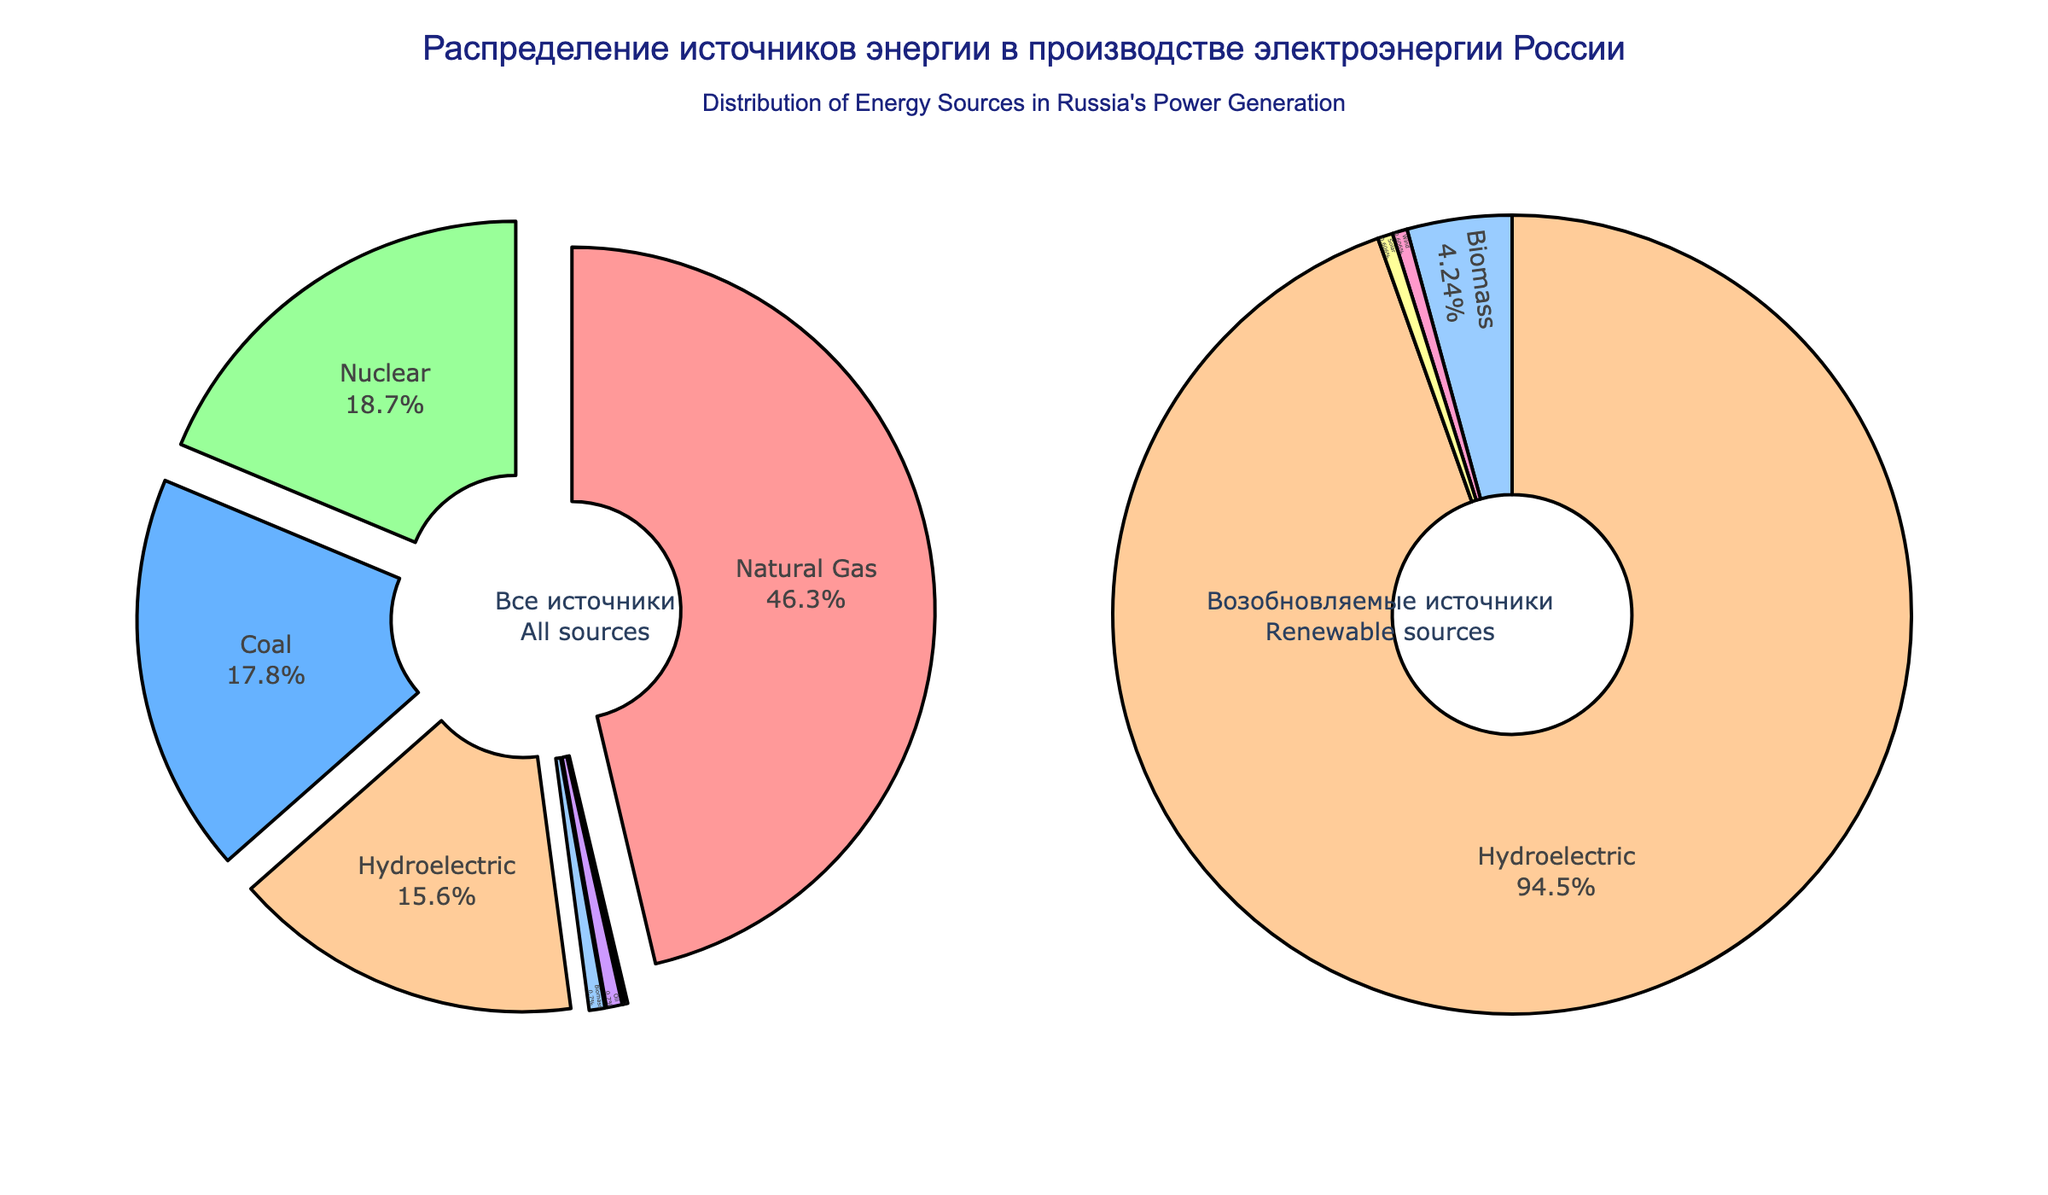What is the most utilized energy source in Russia's power generation? The largest segment of the main pie chart represents the most utilized energy source. From the figure, it is the segment corresponding to "Natural Gas" with the highest percentage.
Answer: Natural Gas How much more percentage does nuclear power contribute compared to coal? To find the difference, identify the percentages for Nuclear and Coal from the main pie chart. Nuclear is 18.7% and Coal is 17.8%. Subtract Coal's percentage from Nuclear's percentage: 18.7 - 17.8.
Answer: 0.9 What is the total percentage of renewable sources in Russia's power generation? Sum the percentages of all the renewable sources (Wind, Solar, Biomass, Hydroelectric) from the main pie chart: 15.6% + 0.1% + 0.1% + 0.7%.
Answer: 16.5 Which energy source has the smallest contribution and what is its value? The smallest segments in the main pie chart are Wind and Solar, both having the same smallest contribution value.
Answer: Wind and Solar, 0.1% Are oil and biomass contributing equally to Russia's power generation? Compare the contributions of Oil and Biomass from the main pie chart. Both have the same percentage of 0.7%.
Answer: Yes What is the combined percentage contribution of all non-renewable energy sources? The non-renewable sources listed are Natural Gas, Coal, Nuclear, Oil. Sum their percentages from the figure: 46.3% + 17.8% + 18.7% + 0.7%.
Answer: 83.5% What percentage of Russia's power generation is supplied by hydroelectric energy? Locate the segment corresponding to Hydroelectric in the main pie chart and read the percentage.
Answer: 15.6% Compare and determine whether coal or nuclear power has a greater share in Russia's power generation, and by how much. From the main pie chart, find the percentages for Coal (17.8%) and Nuclear (18.7%). Subtract Coal's percentage from Nuclear's percentage: 18.7 - 17.8.
Answer: Nuclear by 0.9% Which segment color represents the least utilized renewable source? Identify the color of the smallest segment in the renewable sources pie chart, which corresponds to Wind and Solar.
Answer: Red (for Wind), Yellow (for Solar) 